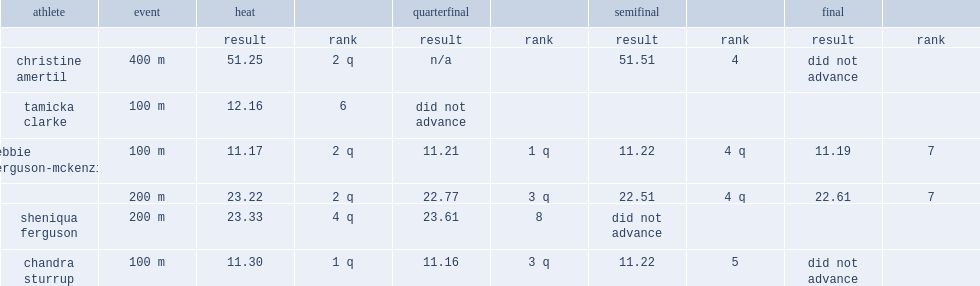At the finals, what is the result for ferguson in the 2008 summer olympics's 100 m race? 11.19. 